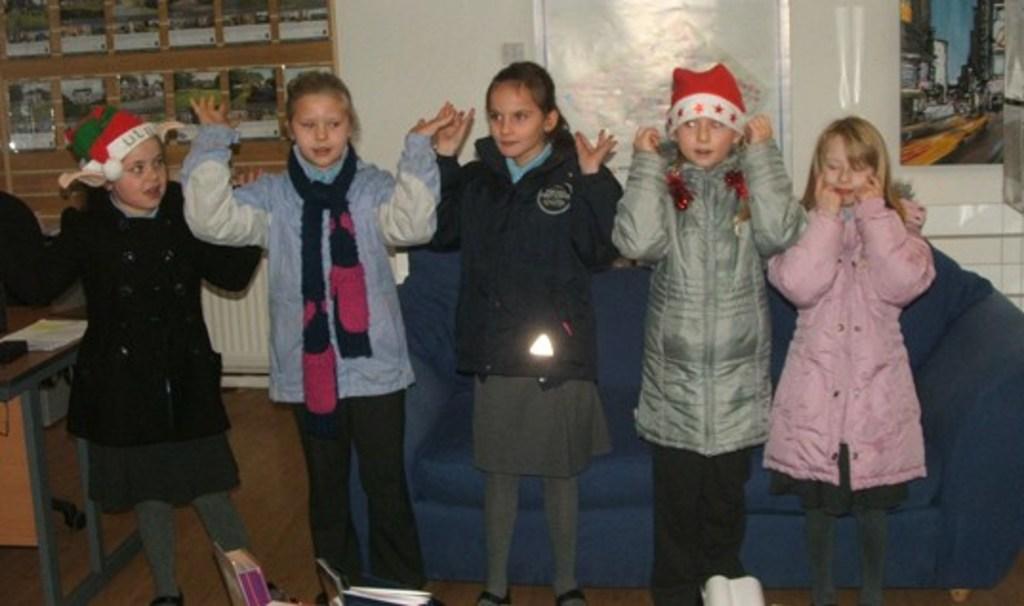How would you summarize this image in a sentence or two? In this image we can see a few people standing, behind them we can see a sofa and a table with some objects on it, there are some books, in the background we can see some posters with images. 